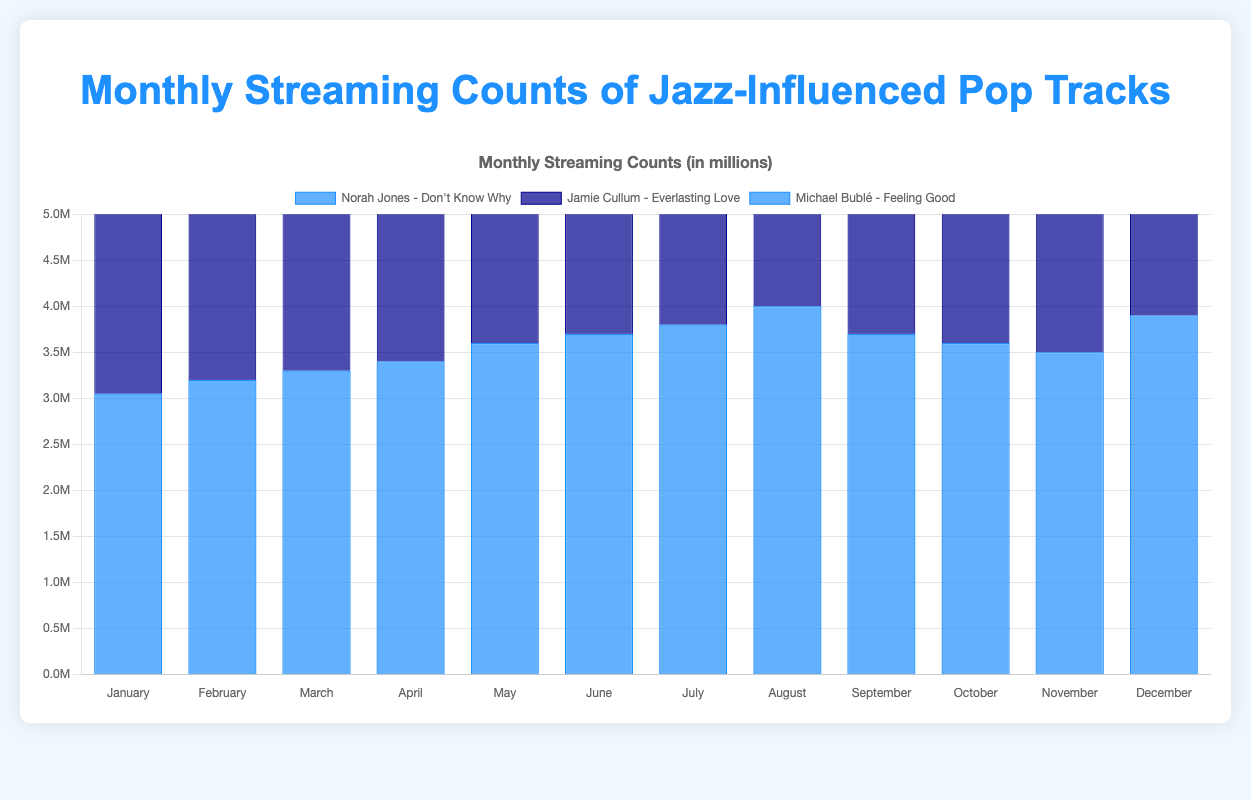What was the monthly streaming count for "Jamie Cullum - Everlasting Love" in August? Looking at the August data bar for "Jamie Cullum - Everlasting Love", we can see the count.
Answer: 3,000,000 Which month had the highest streaming count for "Norah Jones - Don't Know Why"? By comparing the heights of the blue bars for "Norah Jones - Don't Know Why" across all months, we can see that August has the highest bar.
Answer: August What is the total streaming count for "Michael Bublé - Feeling Good" for the first three months? Summing up the values for January, February, and March for "Michael Bublé - Feeling Good" (2,800,000 + 2,900,000 + 3,100,000) results in 8,800,000.
Answer: 8,800,000 How does the streaming count of "Norah Jones - Don't Know Why" in December compare to November? Checking the bar heights for December and November for "Norah Jones - Don't Know Why", December's count (3,900,000) is higher than November's count (3,500,000).
Answer: December's count is higher Which song had the lowest streaming count in January? Comparing the heights of all the bars for January, "Jamie Cullum - Everlasting Love" has the lowest height at 2,200,000.
Answer: "Jamie Cullum - Everlasting Love" What's the average streaming count for "Jamie Cullum - Everlasting Love" across the entire year? Summing up "Jamie Cullum - Everlasting Love" counts from all months (2,200,000 + 2,400,000 + 2,500,000 + 2,600,000 + 2,700,000 + 2,800,000 + 2,900,000 + 3,000,000 + 2,800,000 + 2,700,000 + 2,600,000 + 3,100,000) gives 33,300,000, dividing by 12 results in 2,775,000.
Answer: 2,775,000 In which month did each song have the same streaming count? By examining the chart, we can see that "Norah Jones - Don't Know Why", "Jamie Cullum - Everlasting Love", and "Michael Bublé - Feeling Good" have the same streaming counts as they return to their June values in September respectively (3,700,000, 2,800,000, 3,400,000).
Answer: September 